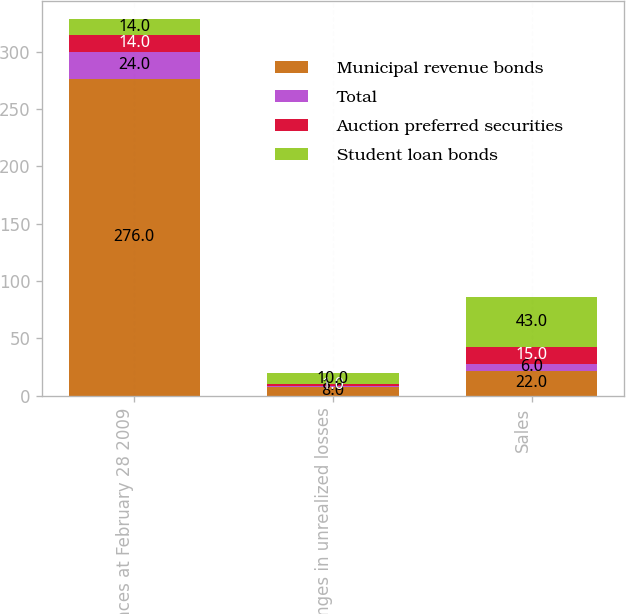<chart> <loc_0><loc_0><loc_500><loc_500><stacked_bar_chart><ecel><fcel>Balances at February 28 2009<fcel>Changes in unrealized losses<fcel>Sales<nl><fcel>Municipal revenue bonds<fcel>276<fcel>8<fcel>22<nl><fcel>Total<fcel>24<fcel>1<fcel>6<nl><fcel>Auction preferred securities<fcel>14<fcel>1<fcel>15<nl><fcel>Student loan bonds<fcel>14<fcel>10<fcel>43<nl></chart> 